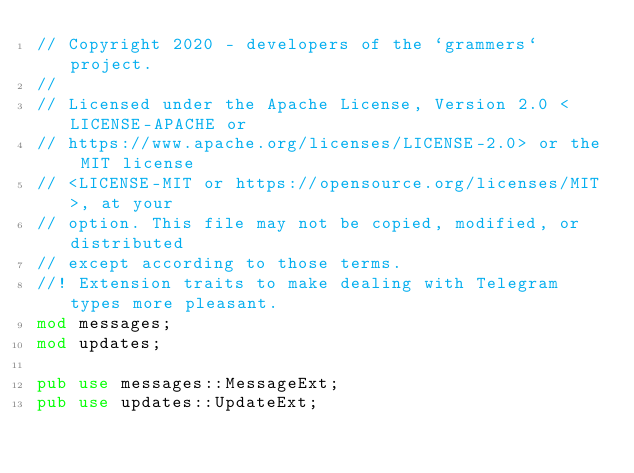<code> <loc_0><loc_0><loc_500><loc_500><_Rust_>// Copyright 2020 - developers of the `grammers` project.
//
// Licensed under the Apache License, Version 2.0 <LICENSE-APACHE or
// https://www.apache.org/licenses/LICENSE-2.0> or the MIT license
// <LICENSE-MIT or https://opensource.org/licenses/MIT>, at your
// option. This file may not be copied, modified, or distributed
// except according to those terms.
//! Extension traits to make dealing with Telegram types more pleasant.
mod messages;
mod updates;

pub use messages::MessageExt;
pub use updates::UpdateExt;
</code> 